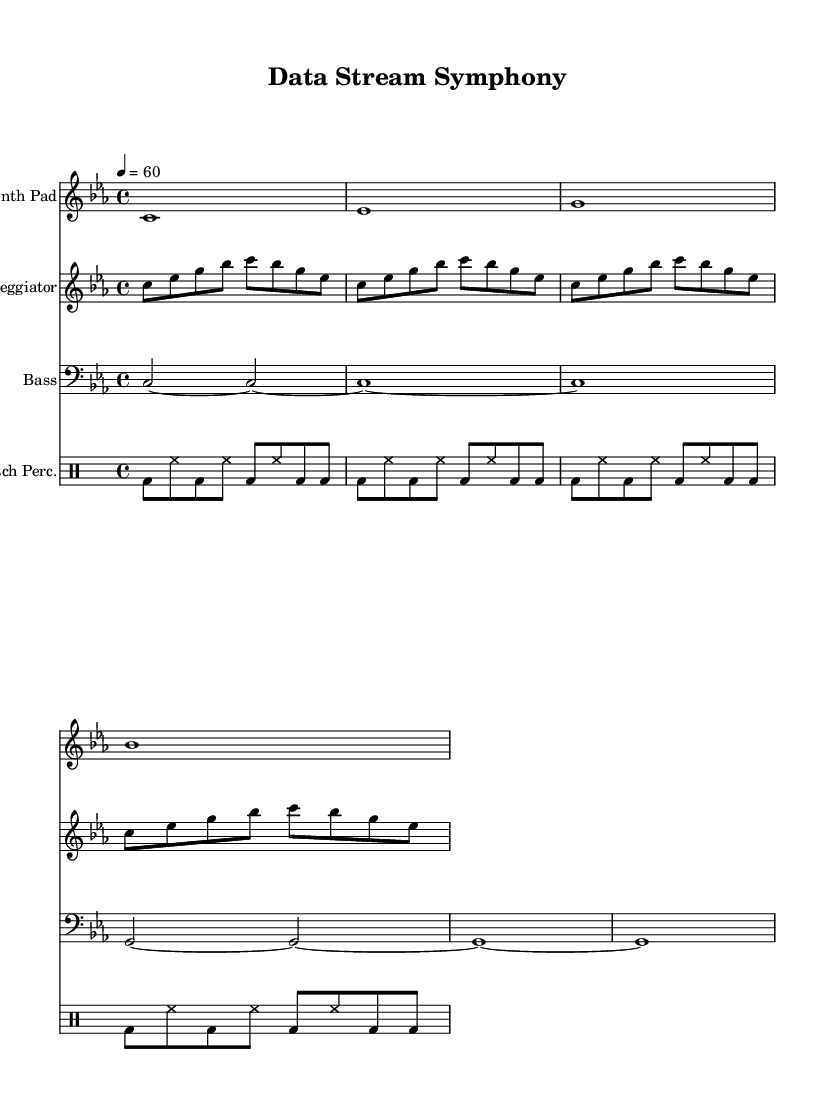What is the key signature of this music? The key signature is C minor, which has three flats: B flat, E flat, and A flat. This can be identified in the key signature section at the beginning of the score.
Answer: C minor What is the time signature of this piece? The time signature is 4/4, indicated by the fraction at the start of the music. This means there are four beats per measure, and each beat is a quarter note.
Answer: 4/4 What is the tempo marking for this piece? The tempo marking is 60 beats per minute, denoted by "4 = 60" in the global section of the score. This suggests a moderate pace for the music.
Answer: 60 Which rhythmic pattern is used in glitch percussion? The glitch percussion employs a repeated rhythmic pattern of bass drum and hi-hat, which can be seen in the drummode section where there are patterns of "bd" for bass drum and "hh" for hi-hat.
Answer: Bass drum and hi-hat What note duration is primarily used in the bass part? The bass part predominantly uses half notes, as indicated by the "c2" and "g2" notations, showing that these notes are held for two beats each.
Answer: Half notes What electronic music technique is exemplified by the arpeggiator part? The arpeggiator part exemplifies the use of an arpeggio, where notes of a chord are played in succession rather than simultaneously, as seen in the sequential arrangement of notes.
Answer: Arpeggio 